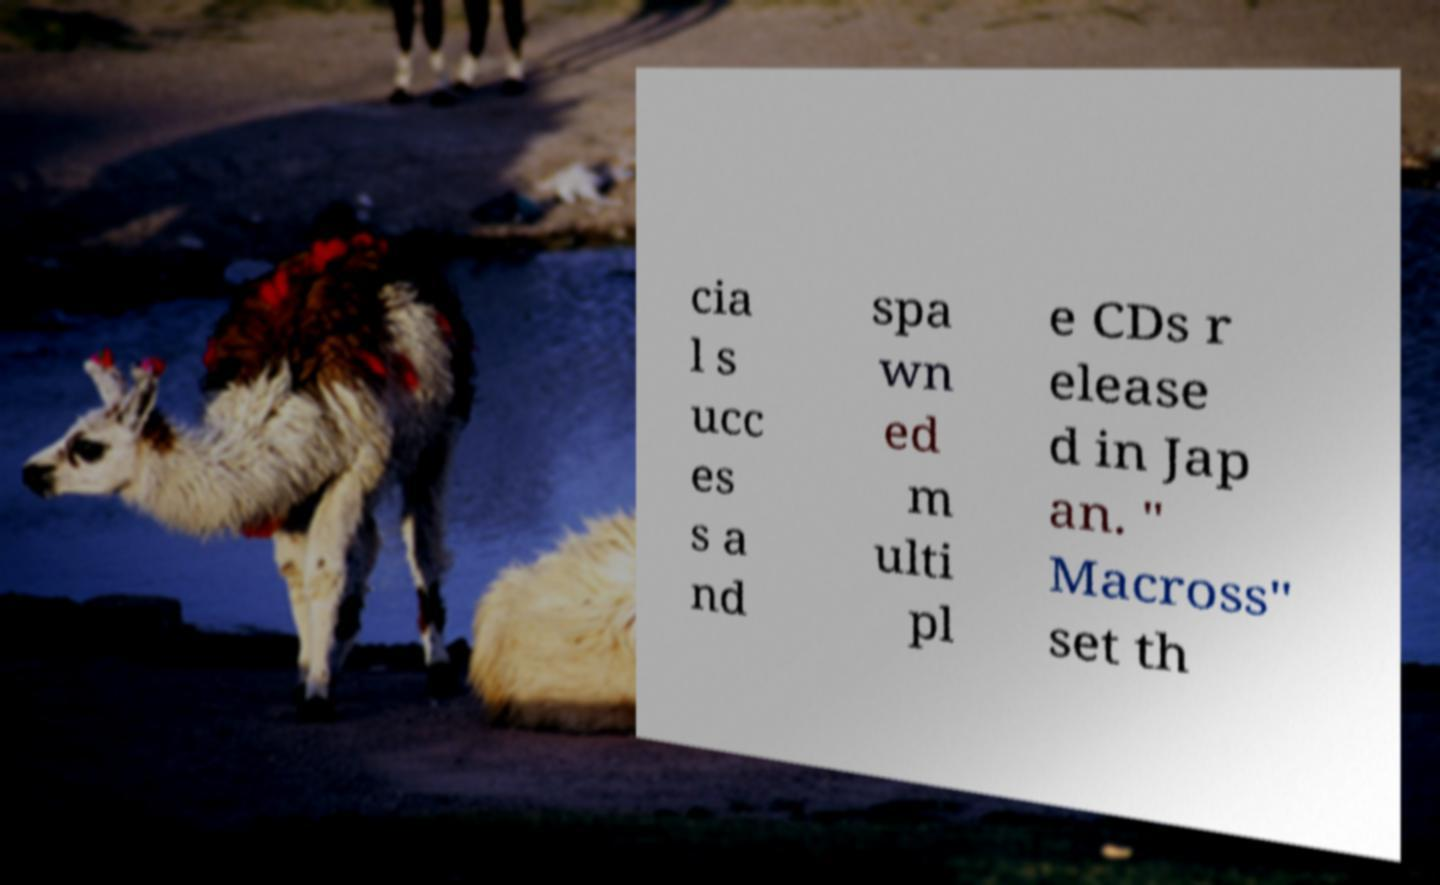Could you extract and type out the text from this image? cia l s ucc es s a nd spa wn ed m ulti pl e CDs r elease d in Jap an. " Macross" set th 